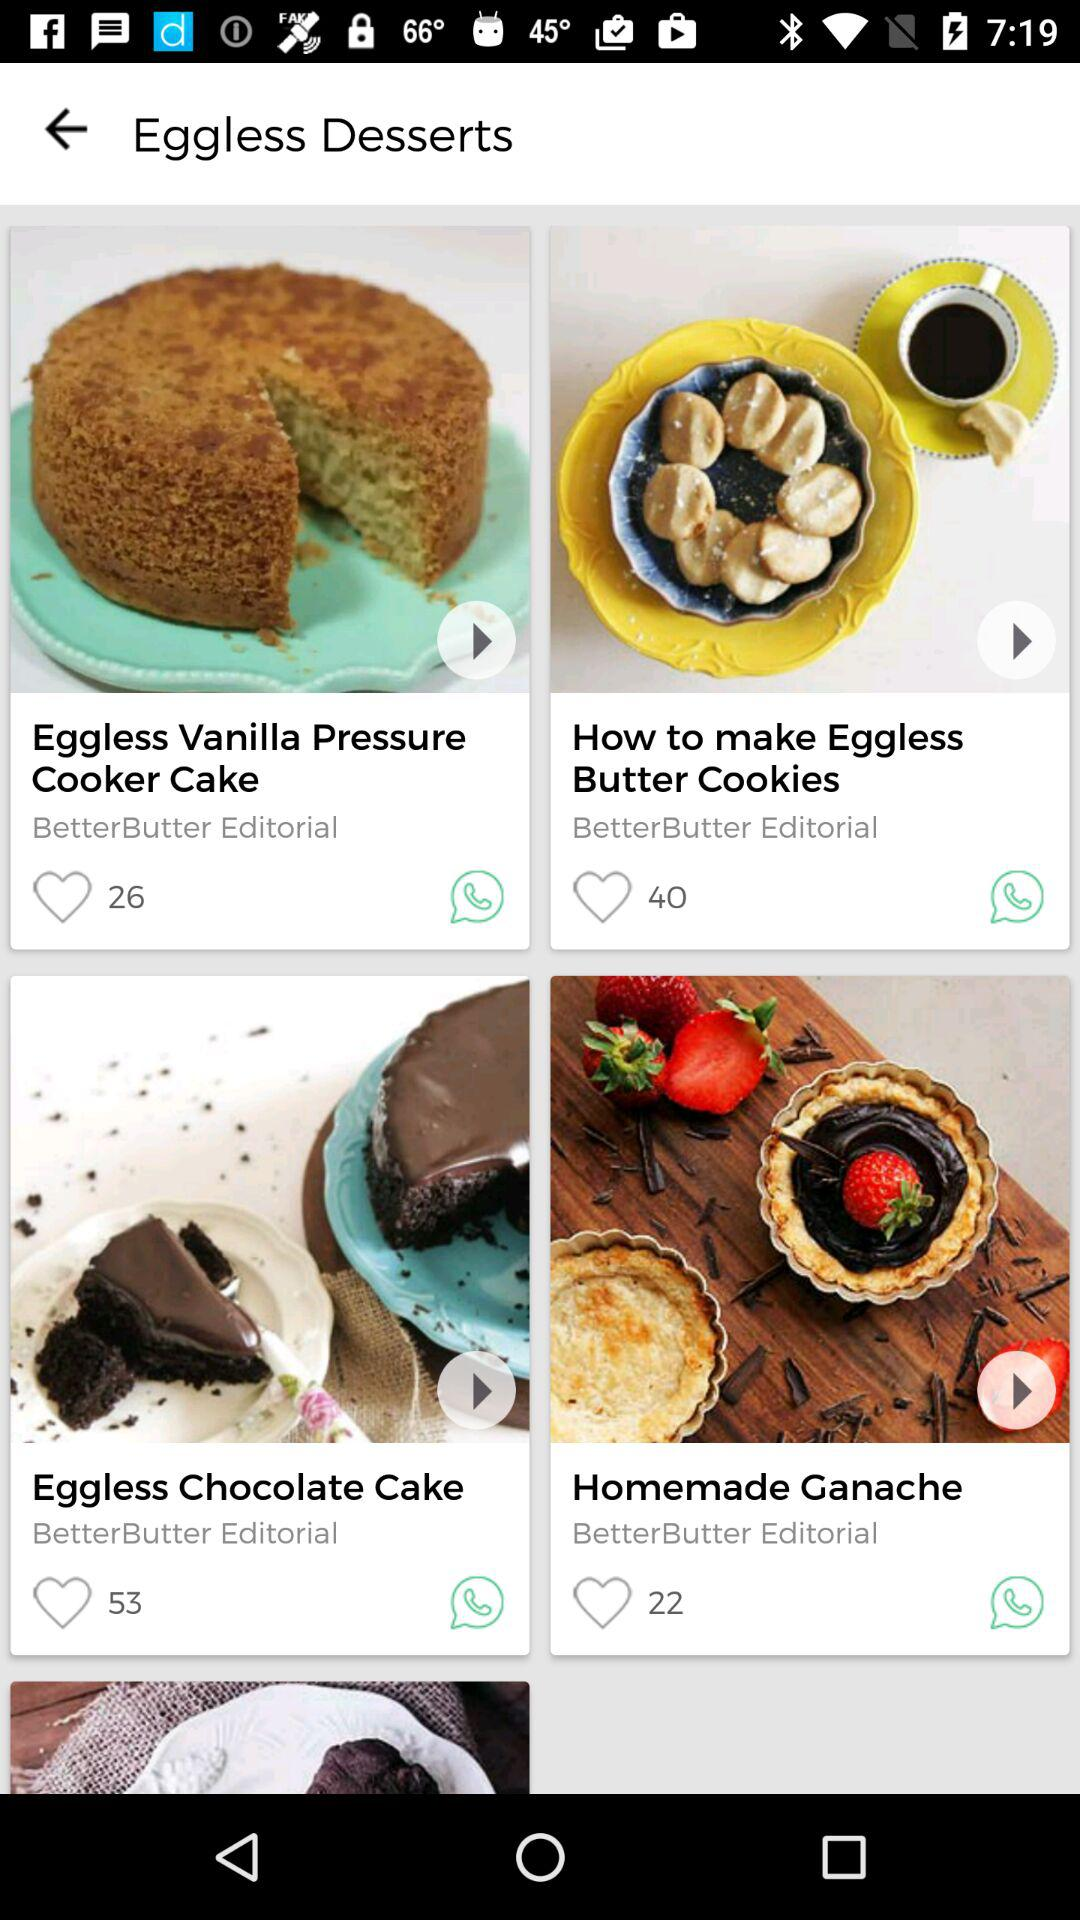What is the name of the cake that can be made in a pressure cooker? The name of the cake is Eggless Vanilla Pressure Cooker Cake. 